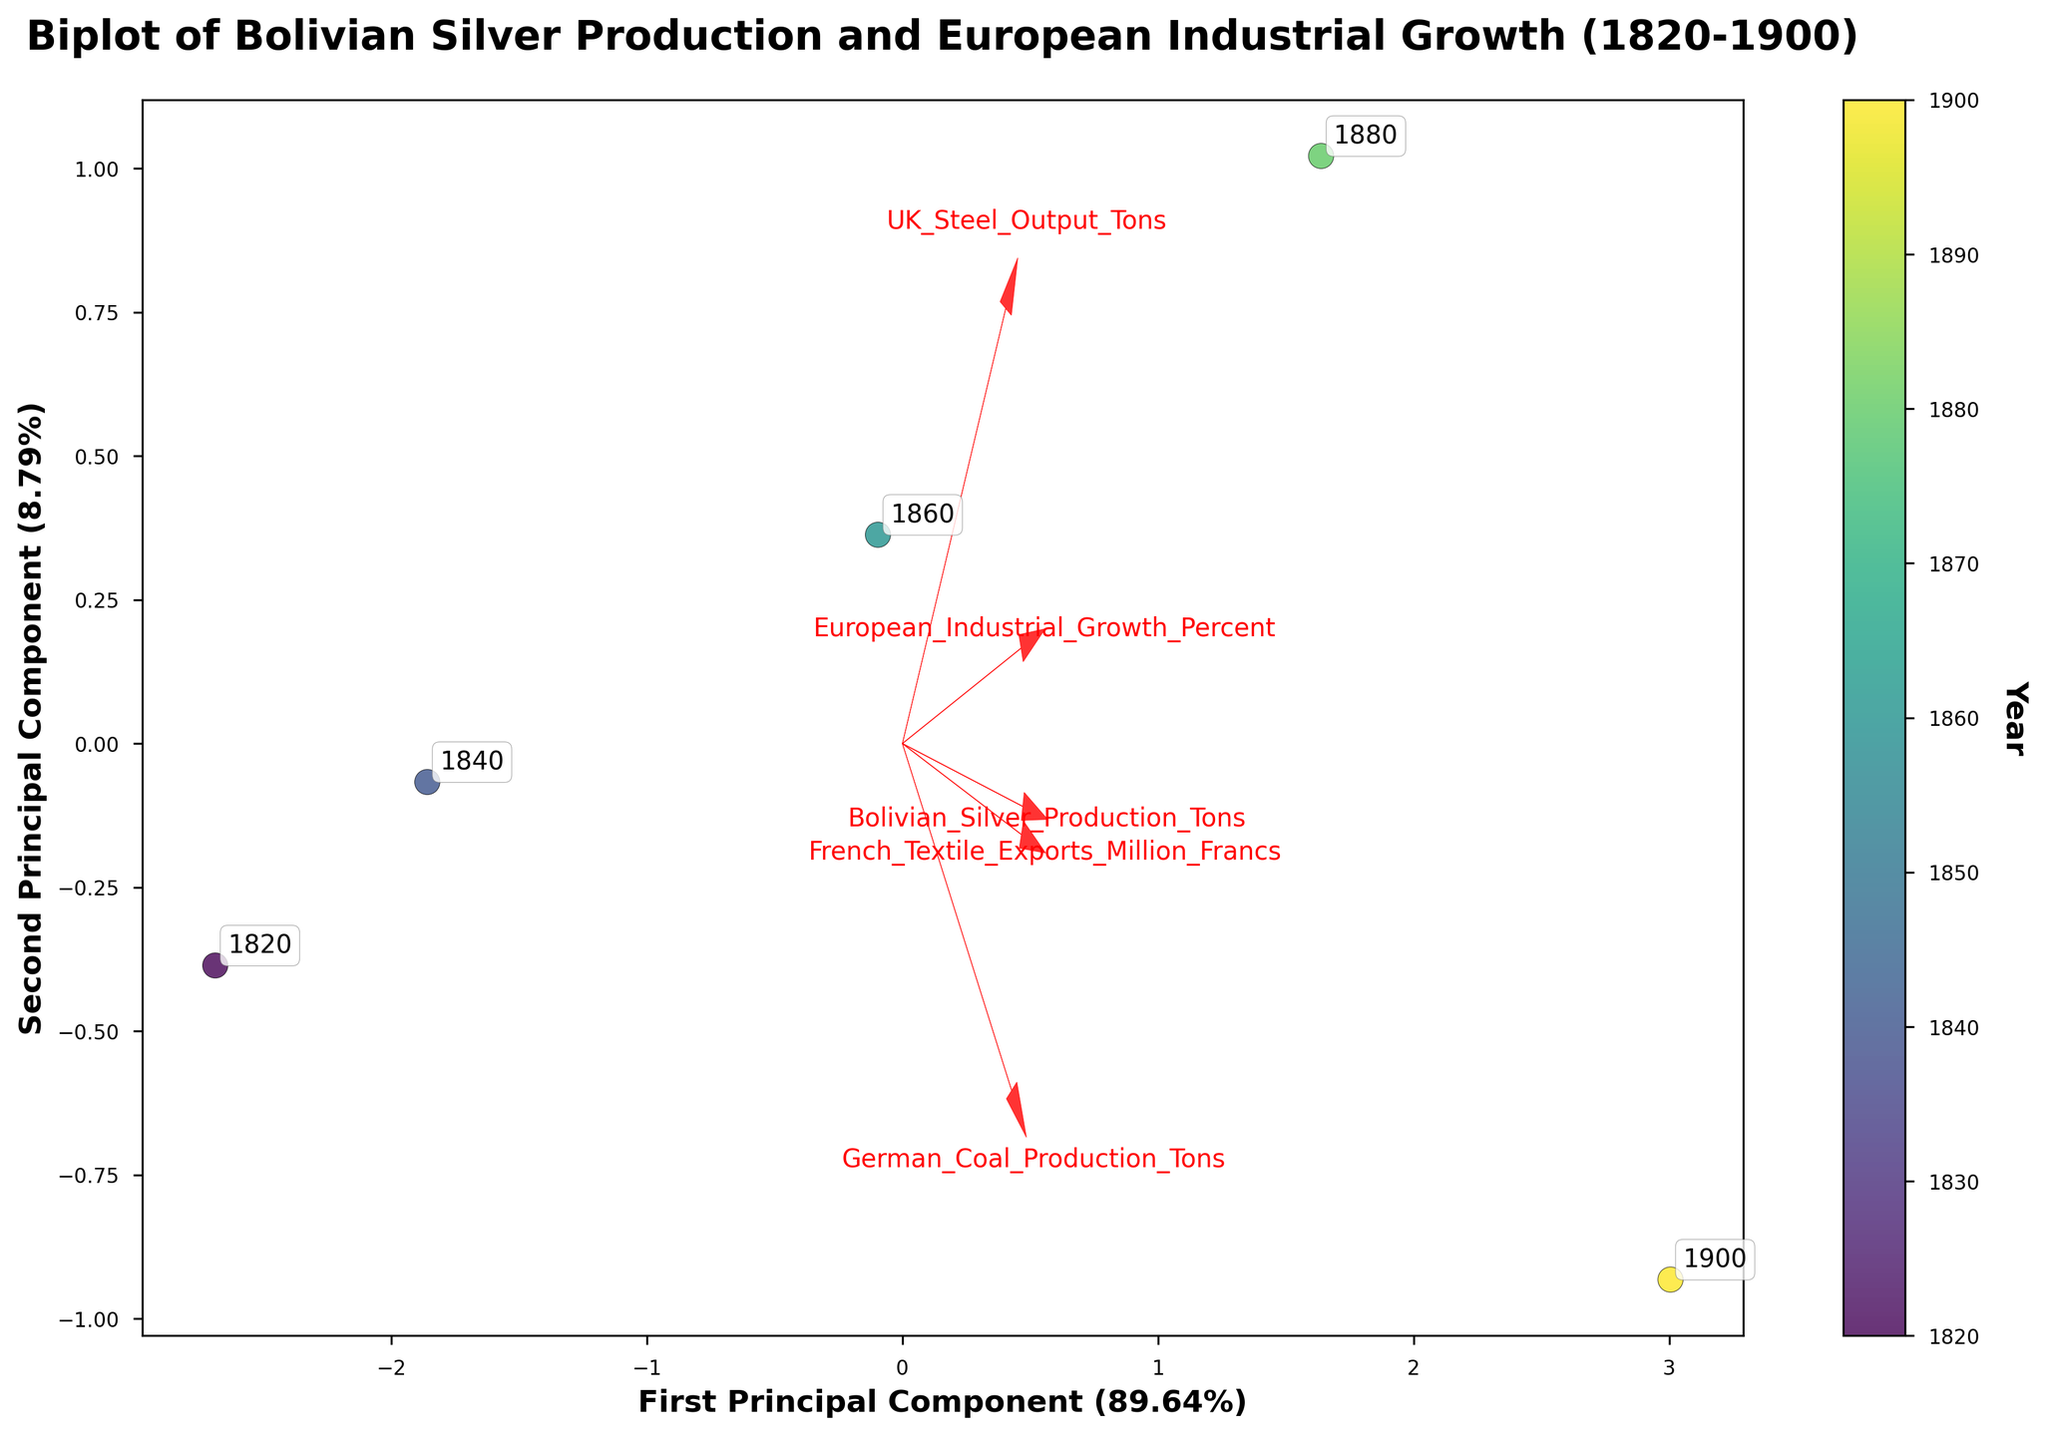What's the title of the figure? The title of the figure is prominently displayed at the top and reads, "Biplot of Bolivian Silver Production and European Industrial Growth (1820-1900)."
Answer: Biplot of Bolivian Silver Production and European Industrial Growth (1820-1900) How many arrows are drawn to represent the features in the data? Arrows are drawn to represent each of the features/variables, which are Bolivian Silver Production, European Industrial Growth, UK Steel Output, German Coal Production, and French Textile Exports.
Answer: 5 Which principal component explains more variance in the data, and what is the exact percentage it explains? The figure has axis labels showing the explained variance for each principal component. The first principal component explains more variance, and the exact percentage is approximately 59.59%.
Answer: First Principal Component (59.59%) What are the endpoints of the arrows for Bolivian Silver Production and German Coal Production? The endpoints of the arrows are found by looking at where each labeled arrow "Bolivian Silver Production" and "German Coal Production" finishes on the biplot.
Answer: Bolivian Silver Production: positive X and Y direction, German Coal Production: positive X direction, reverse Y direction Between 1820 and 1900, how did the industrial growth in Europe compare to Bolivian Silver Production? Referencing the color gradient (lighter colors for earlier years and darker colors for later years) and the positioning of the points, European industrial growth increased steadily, as did Bolivian silver production, indicating a positive correlation over time.
Answer: Increased steadily for both Which feature has the greatest loading on the first principal component? The feature with the greatest loading has the longest arrow pointing predominantly along the axis of the first principal component. By observation, "German Coal Production" has the longest arrow in the positive direction for the first component.
Answer: German Coal Production Are the years closely clustered, or are they spread out in the biplot? By examining the distribution of the data points representing the years, we can see if they form a tight cluster or are more widely dispersed across the quadrant of the principal components. The years are generally spread out, indicating differentiation over time.
Answer: Spread out Does Bolivian Silver Production have a positive or negative correlation with European Industrial Growth? Looking at the direction of the arrows for both Bolivian Silver Production and European Industrial Growth, if they point in the same general direction, there is a positive correlation, otherwise, there may be a negative correlation. Both arrows point in the same general direction (positive X and Y), indicating a positive correlation.
Answer: Positive correlation In the biplot, how are the years ordered from 1820 to 1900? Referring to the color gradient indicating years, we can look at the position of each data point and its annotation to determine the order in the biplot. The points progress from the bottom-left (1820) toward the top-right (1900) in a generally linear manner.
Answer: Bottom-left to top-right 